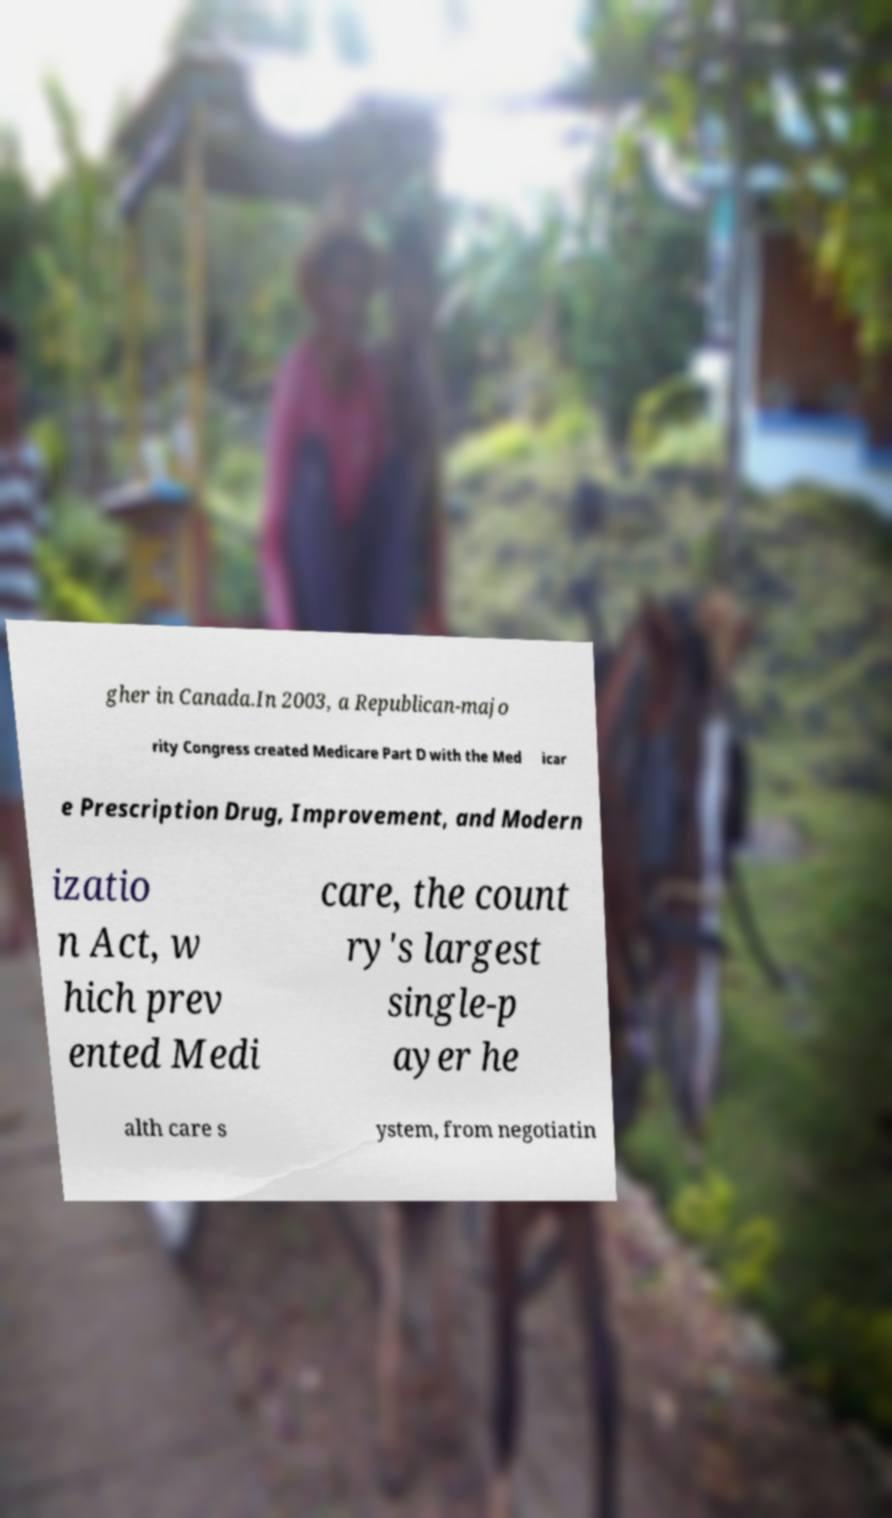Please identify and transcribe the text found in this image. gher in Canada.In 2003, a Republican-majo rity Congress created Medicare Part D with the Med icar e Prescription Drug, Improvement, and Modern izatio n Act, w hich prev ented Medi care, the count ry's largest single-p ayer he alth care s ystem, from negotiatin 